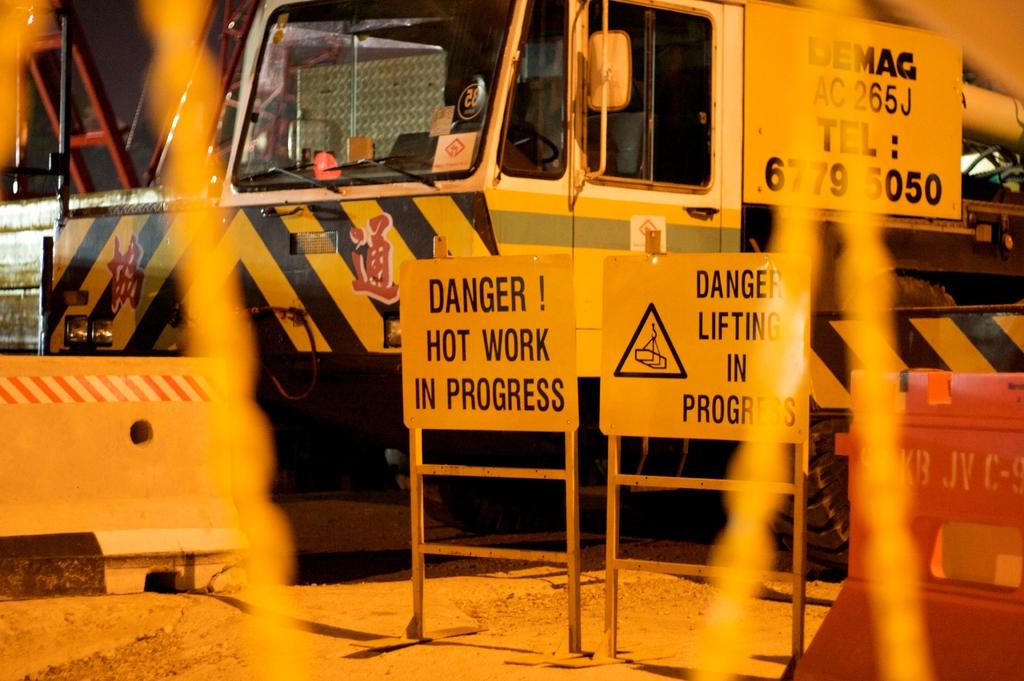What does the danger! sign warn you is happening?
Offer a very short reply. Hot work in progress. 